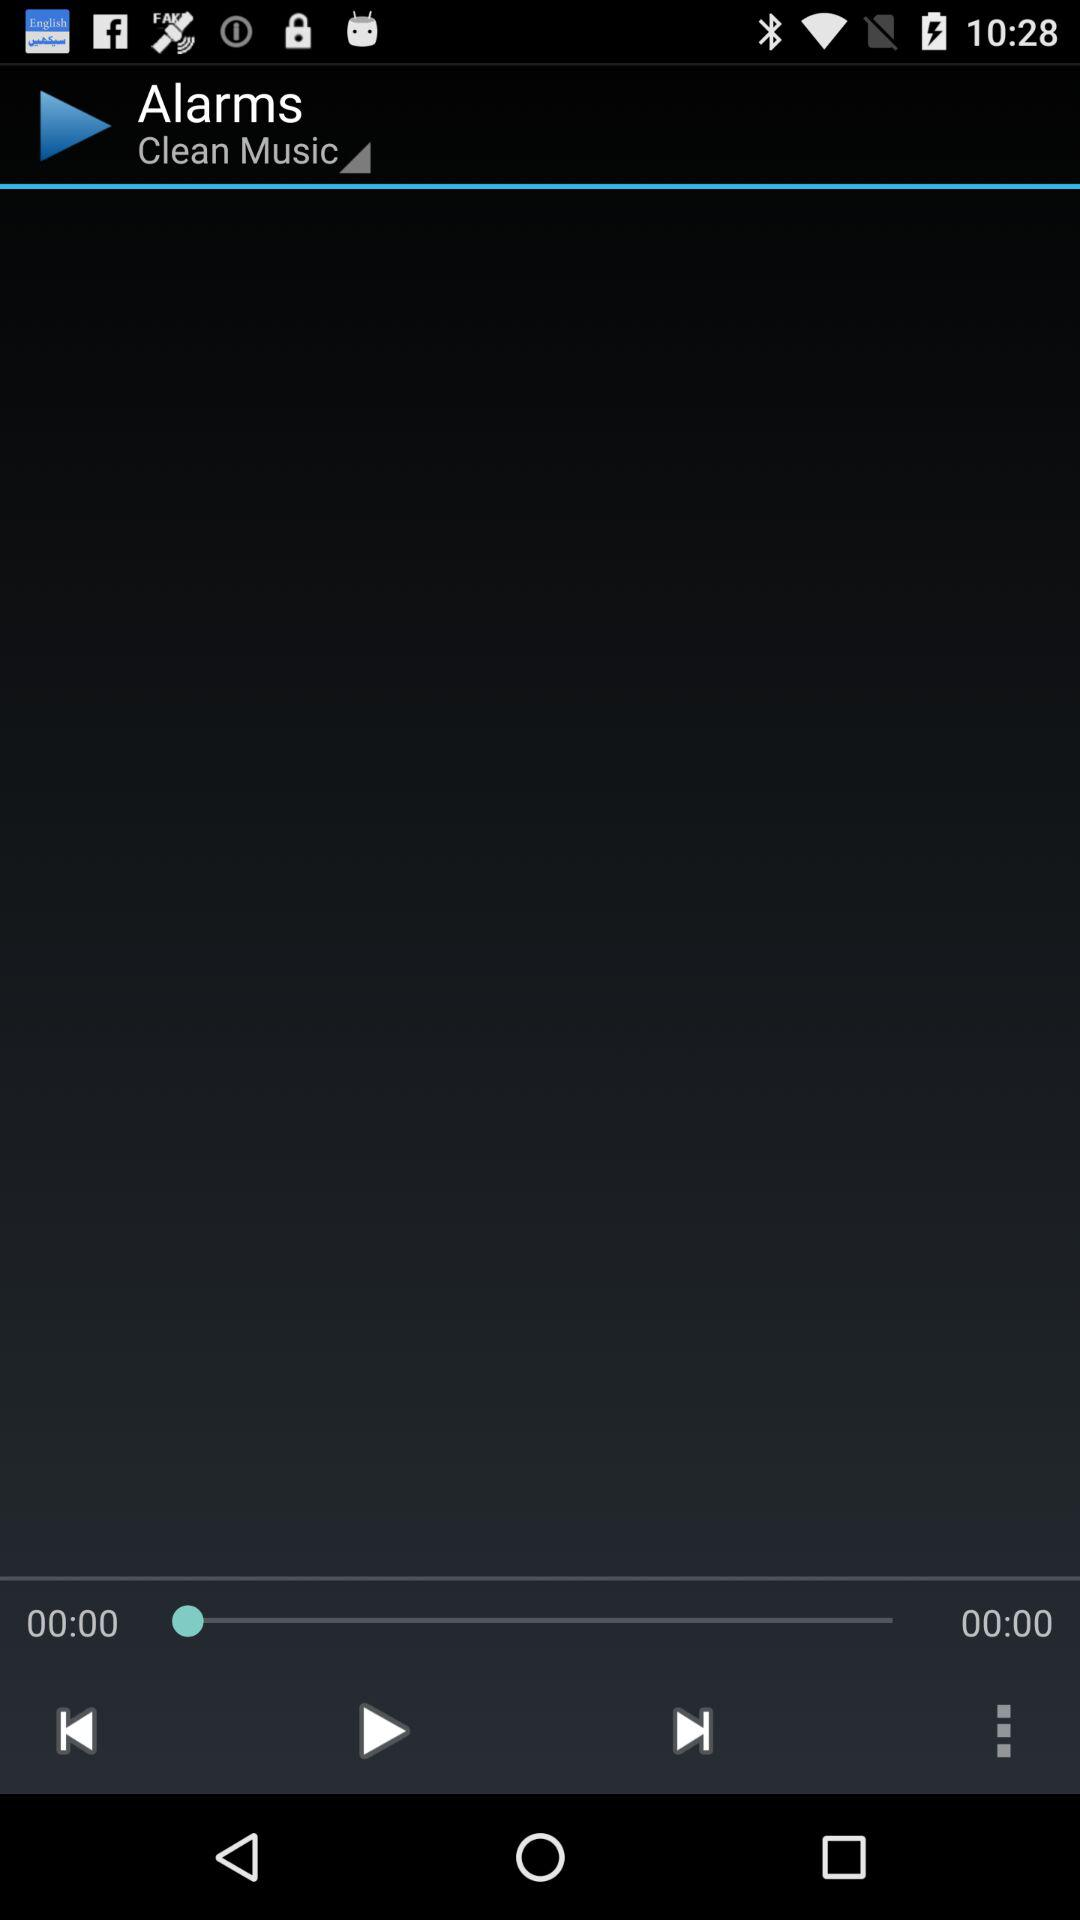How many alarms are listed?
When the provided information is insufficient, respond with <no answer>. <no answer> 